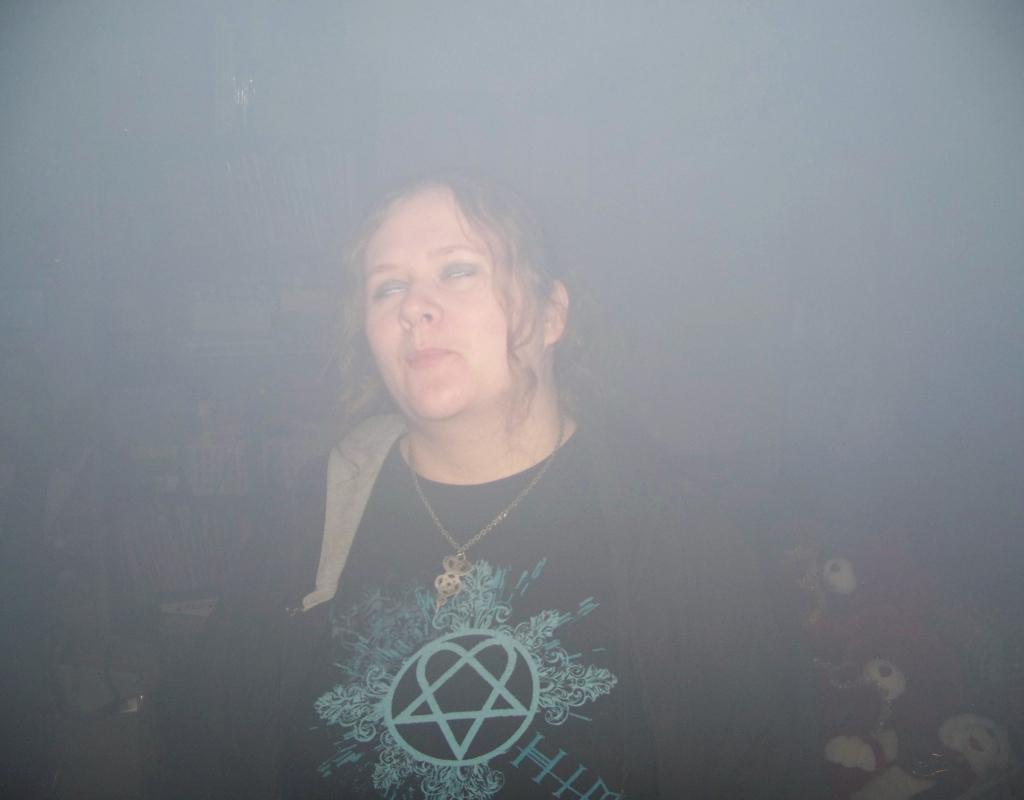Please provide a concise description of this image. In the image there is a woman and behind the woman there is a soft toy. 